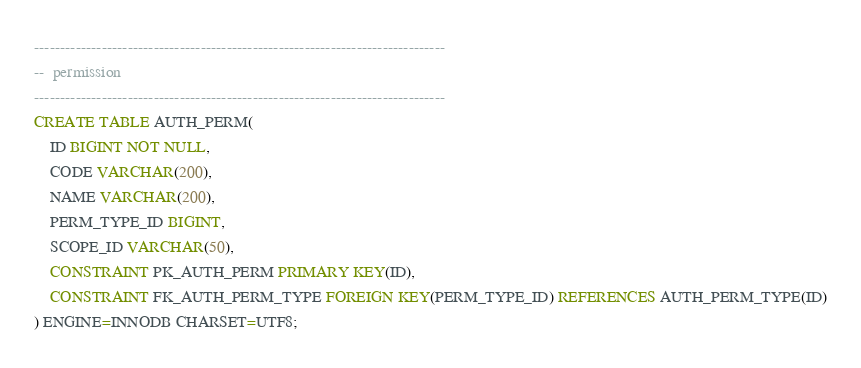Convert code to text. <code><loc_0><loc_0><loc_500><loc_500><_SQL_>

-------------------------------------------------------------------------------
--  permission
-------------------------------------------------------------------------------
CREATE TABLE AUTH_PERM(
    ID BIGINT NOT NULL,
    CODE VARCHAR(200),
    NAME VARCHAR(200),
    PERM_TYPE_ID BIGINT,
    SCOPE_ID VARCHAR(50),
    CONSTRAINT PK_AUTH_PERM PRIMARY KEY(ID),
    CONSTRAINT FK_AUTH_PERM_TYPE FOREIGN KEY(PERM_TYPE_ID) REFERENCES AUTH_PERM_TYPE(ID)
) ENGINE=INNODB CHARSET=UTF8;







</code> 